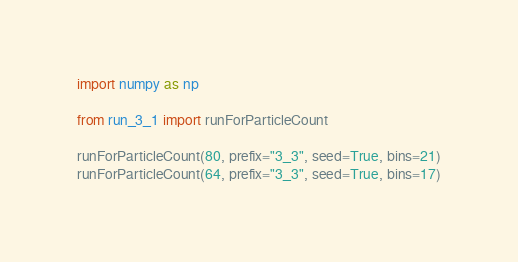Convert code to text. <code><loc_0><loc_0><loc_500><loc_500><_Python_>import numpy as np

from run_3_1 import runForParticleCount

runForParticleCount(80, prefix="3_3", seed=True, bins=21)
runForParticleCount(64, prefix="3_3", seed=True, bins=17)</code> 